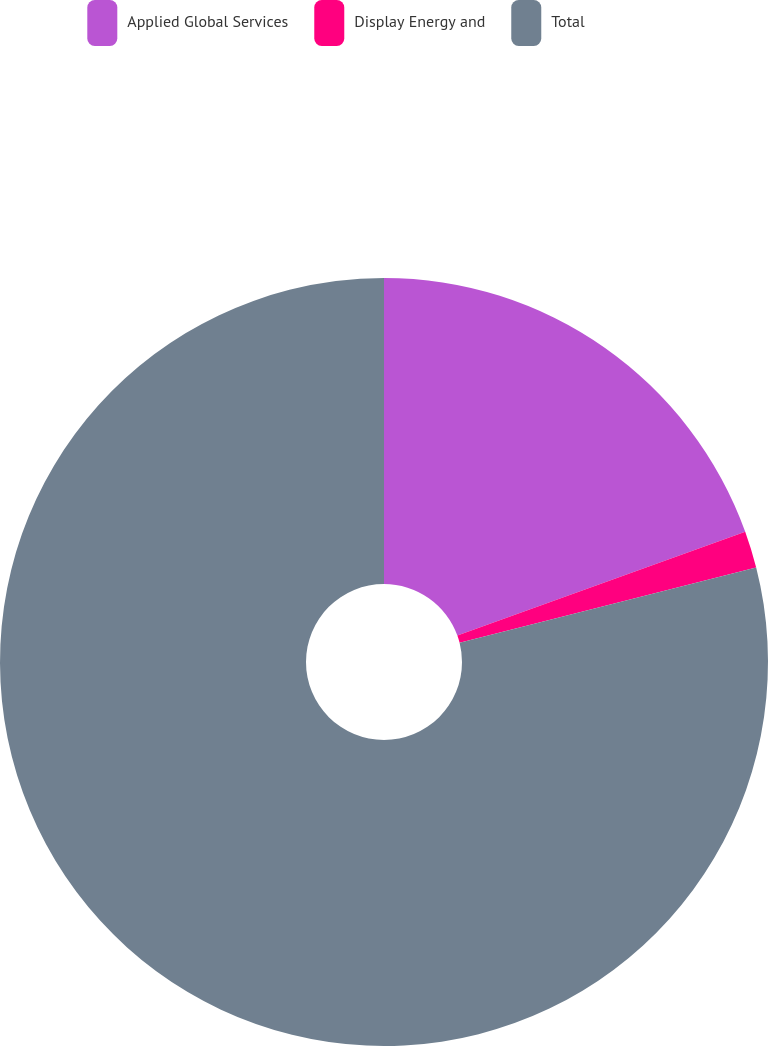Convert chart. <chart><loc_0><loc_0><loc_500><loc_500><pie_chart><fcel>Applied Global Services<fcel>Display Energy and<fcel>Total<nl><fcel>19.49%<fcel>1.55%<fcel>78.96%<nl></chart> 